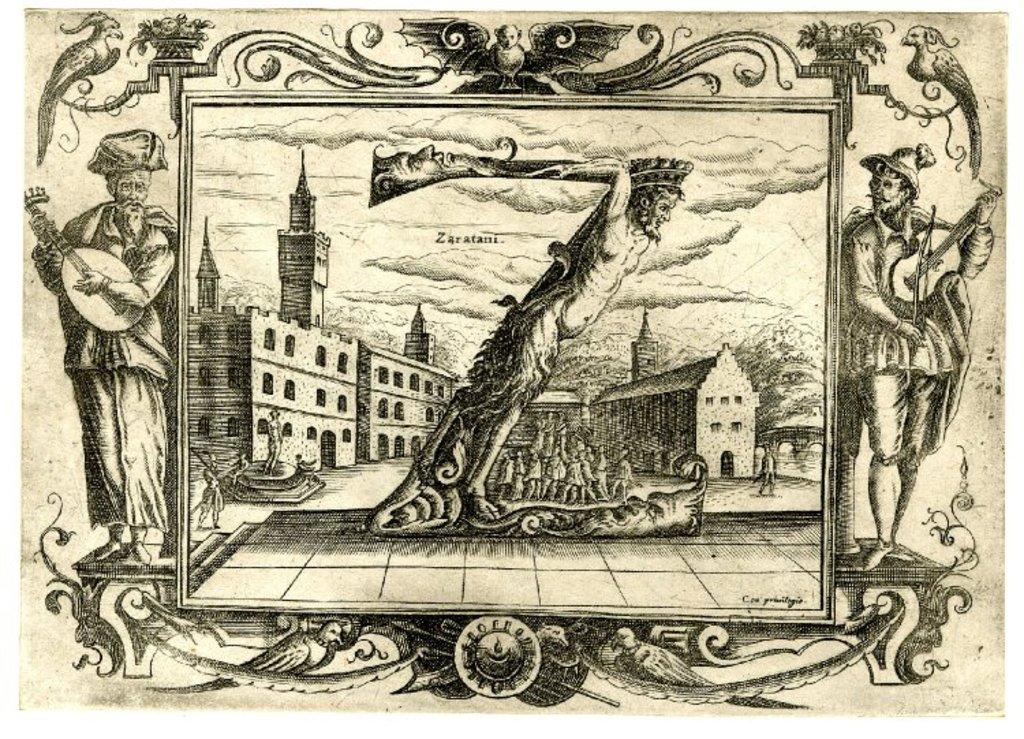What type of visual representation is shown in the image? The image is a poster. What structures are depicted on the poster? There are buildings depicted on the poster. Who or what else can be seen on the poster? There are persons depicted on the poster. What type of noise does the frog make in the image? There is no frog present in the image, so it is not possible to determine what noise it might make. 